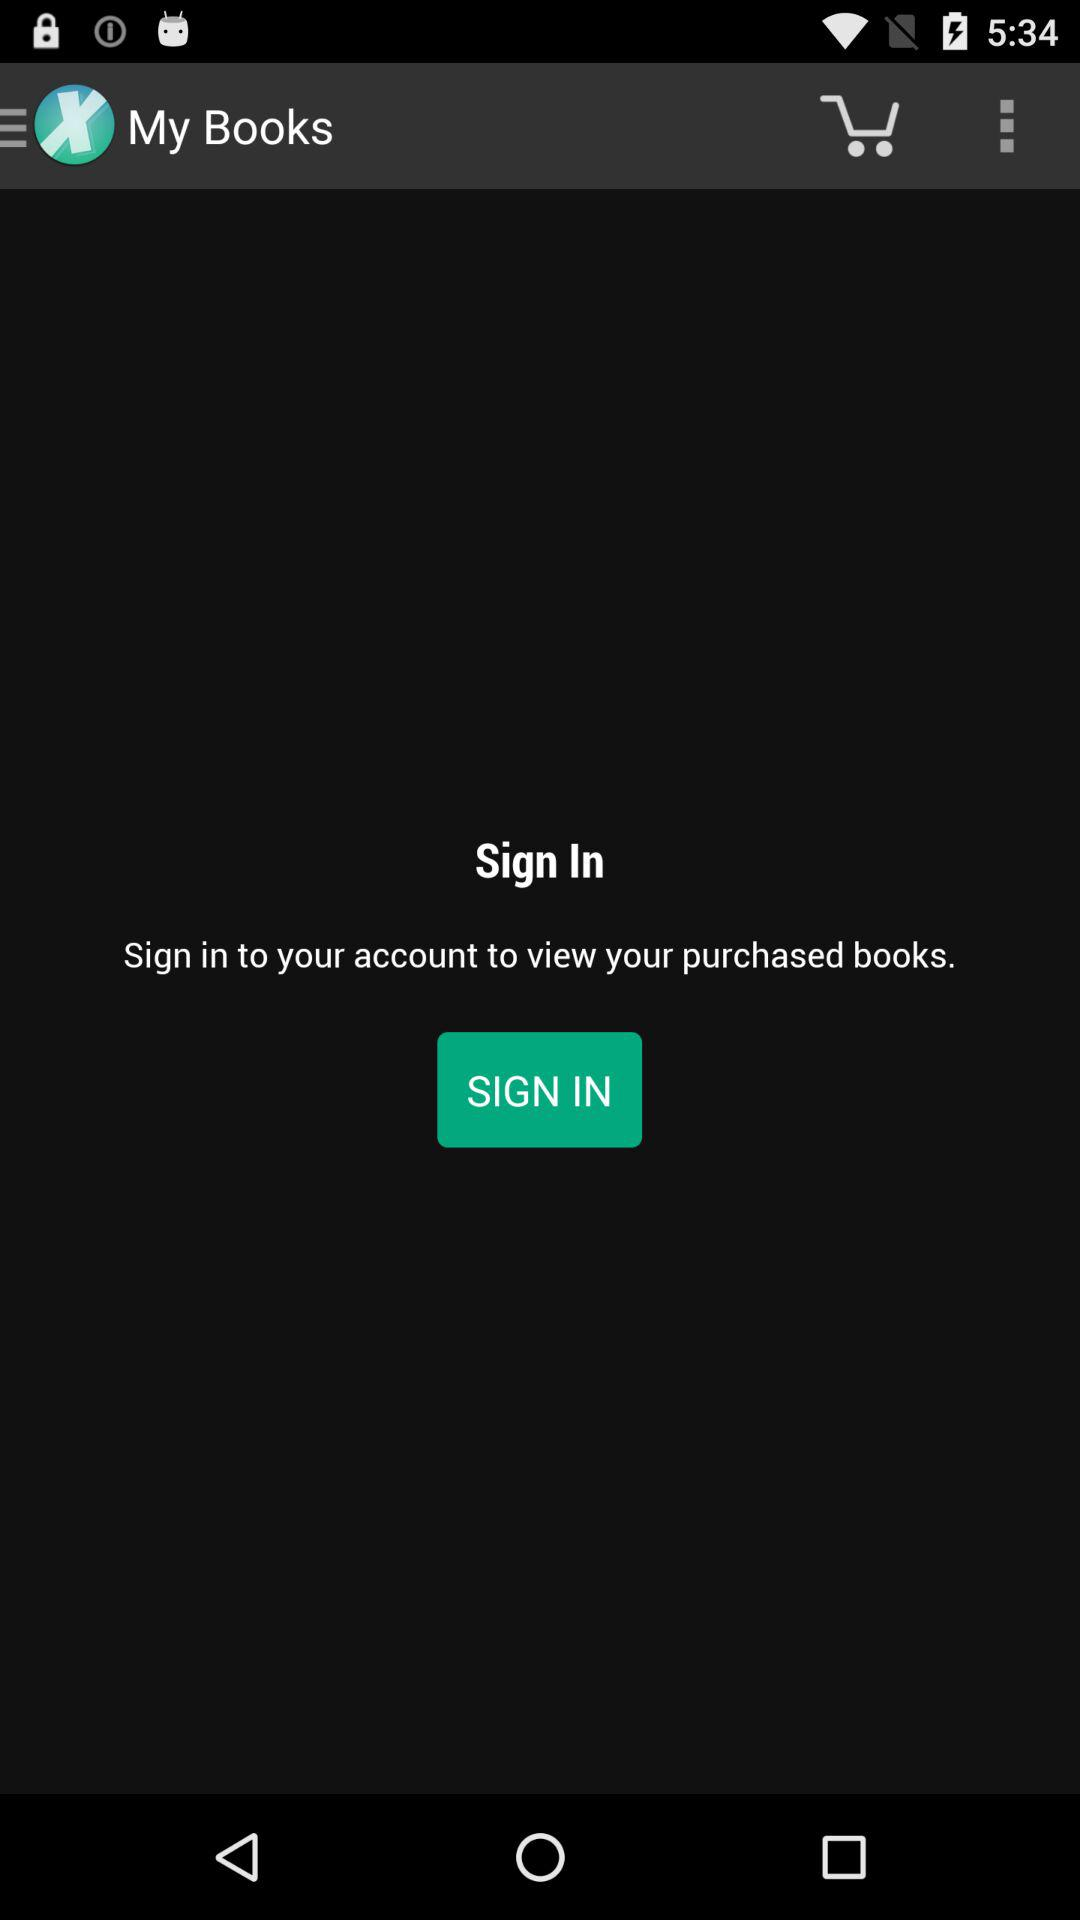What to do to view the purchased books? To view the purchased books, you have to sign in to your account. 